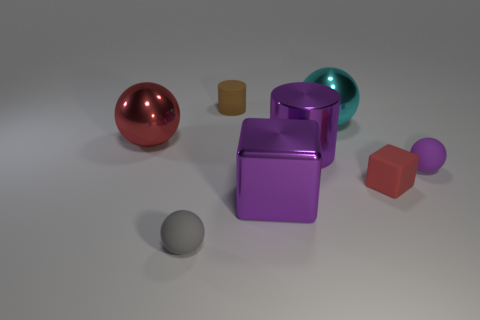Subtract all big cyan balls. How many balls are left? 3 Subtract 0 green cubes. How many objects are left? 8 Subtract all cylinders. How many objects are left? 6 Subtract 3 spheres. How many spheres are left? 1 Subtract all blue balls. Subtract all blue cubes. How many balls are left? 4 Subtract all gray balls. How many purple cubes are left? 1 Subtract all red rubber things. Subtract all big red objects. How many objects are left? 6 Add 1 matte cylinders. How many matte cylinders are left? 2 Add 4 brown rubber cylinders. How many brown rubber cylinders exist? 5 Add 2 large cyan metallic things. How many objects exist? 10 